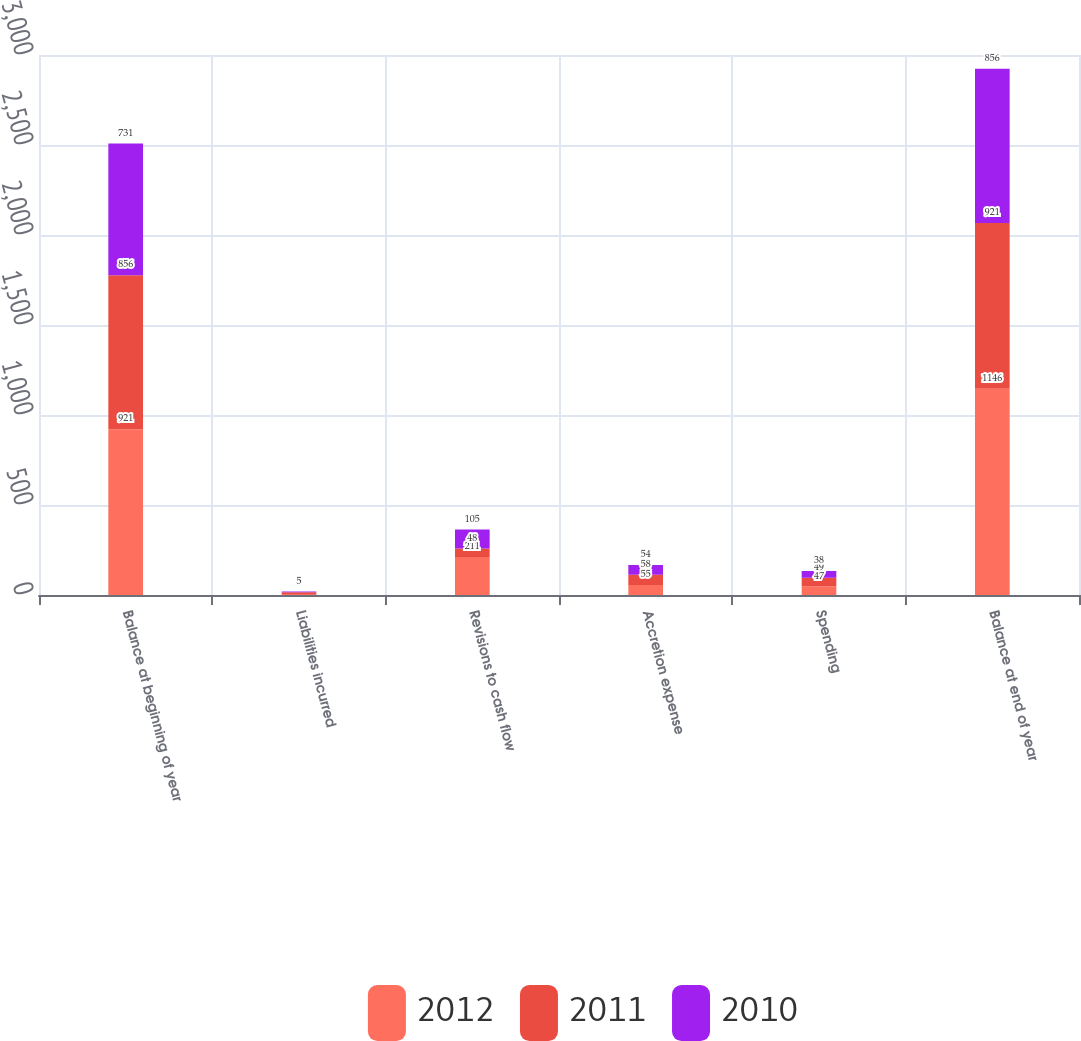Convert chart. <chart><loc_0><loc_0><loc_500><loc_500><stacked_bar_chart><ecel><fcel>Balance at beginning of year<fcel>Liabilities incurred<fcel>Revisions to cash flow<fcel>Accretion expense<fcel>Spending<fcel>Balance at end of year<nl><fcel>2012<fcel>921<fcel>6<fcel>211<fcel>55<fcel>47<fcel>1146<nl><fcel>2011<fcel>856<fcel>9<fcel>48<fcel>58<fcel>49<fcel>921<nl><fcel>2010<fcel>731<fcel>5<fcel>105<fcel>54<fcel>38<fcel>856<nl></chart> 